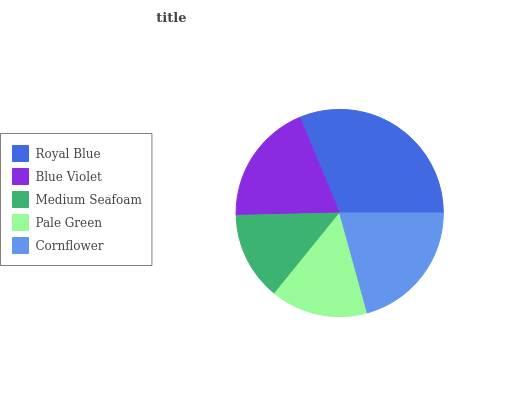Is Medium Seafoam the minimum?
Answer yes or no. Yes. Is Royal Blue the maximum?
Answer yes or no. Yes. Is Blue Violet the minimum?
Answer yes or no. No. Is Blue Violet the maximum?
Answer yes or no. No. Is Royal Blue greater than Blue Violet?
Answer yes or no. Yes. Is Blue Violet less than Royal Blue?
Answer yes or no. Yes. Is Blue Violet greater than Royal Blue?
Answer yes or no. No. Is Royal Blue less than Blue Violet?
Answer yes or no. No. Is Blue Violet the high median?
Answer yes or no. Yes. Is Blue Violet the low median?
Answer yes or no. Yes. Is Medium Seafoam the high median?
Answer yes or no. No. Is Royal Blue the low median?
Answer yes or no. No. 